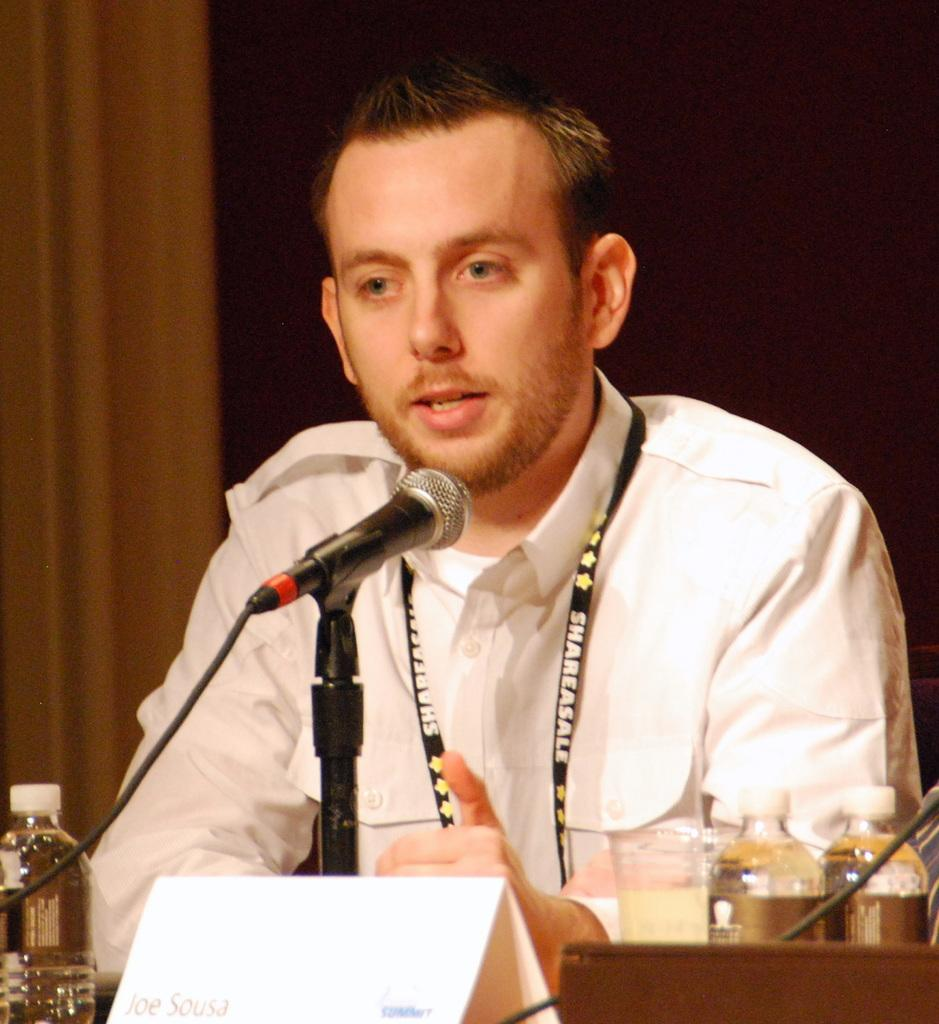Who or what is in the image? There is a person in the image. What is the person doing or interacting with in the image? The person is in front of a microphone. Are there any other objects or items visible in the image? Yes, there is a paper card in the image. Can you describe the location or position of the paper card in the image? The paper card is between bottles. What type of fuel is being used by the person in the image? There is no mention of fuel or any fuel-related activity in the image. 